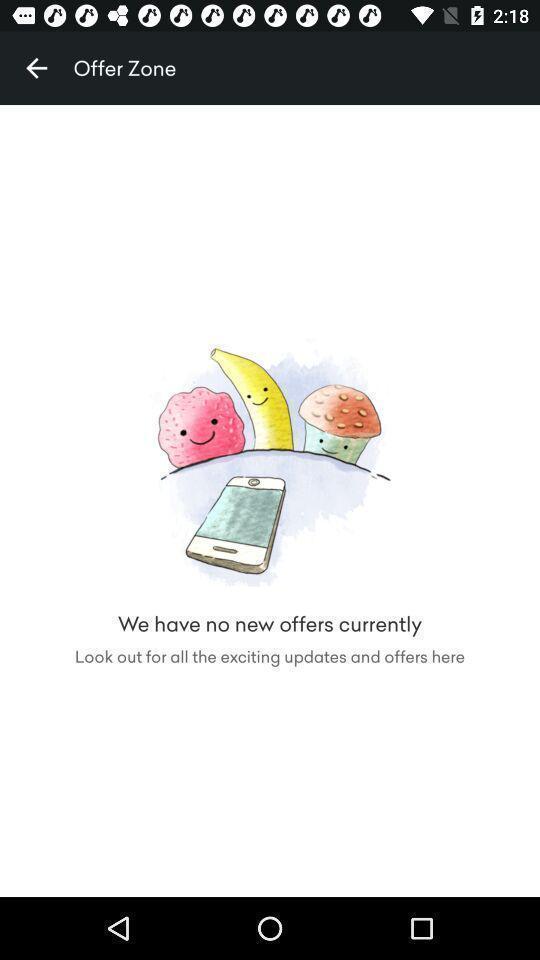Summarize the information in this screenshot. Screen shows offer zone in shopping app. 